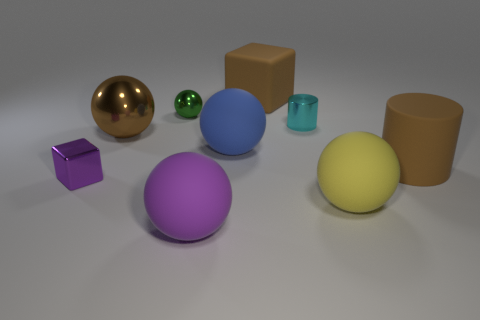What are the different colors of the objects in this image? The image presents objects in several colors, including blue, yellow, purple, brown, gold, and green. Which is the smallest object and what color is it? The smallest object appears to be a small green sphere. 